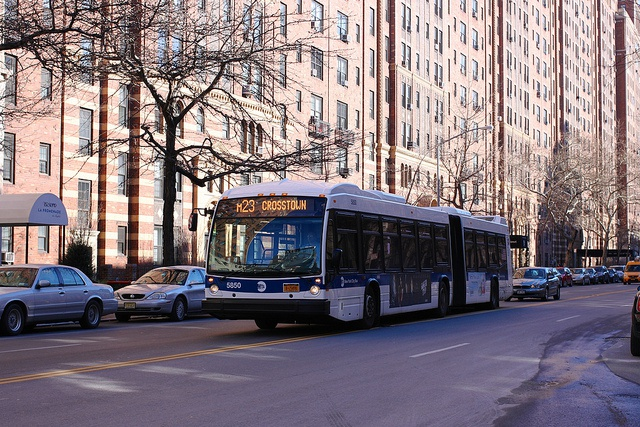Describe the objects in this image and their specific colors. I can see bus in white, black, gray, and navy tones, car in white, black, gray, and navy tones, car in white, black, gray, darkgray, and navy tones, car in white, black, navy, gray, and darkgray tones, and truck in white, black, gray, maroon, and navy tones in this image. 